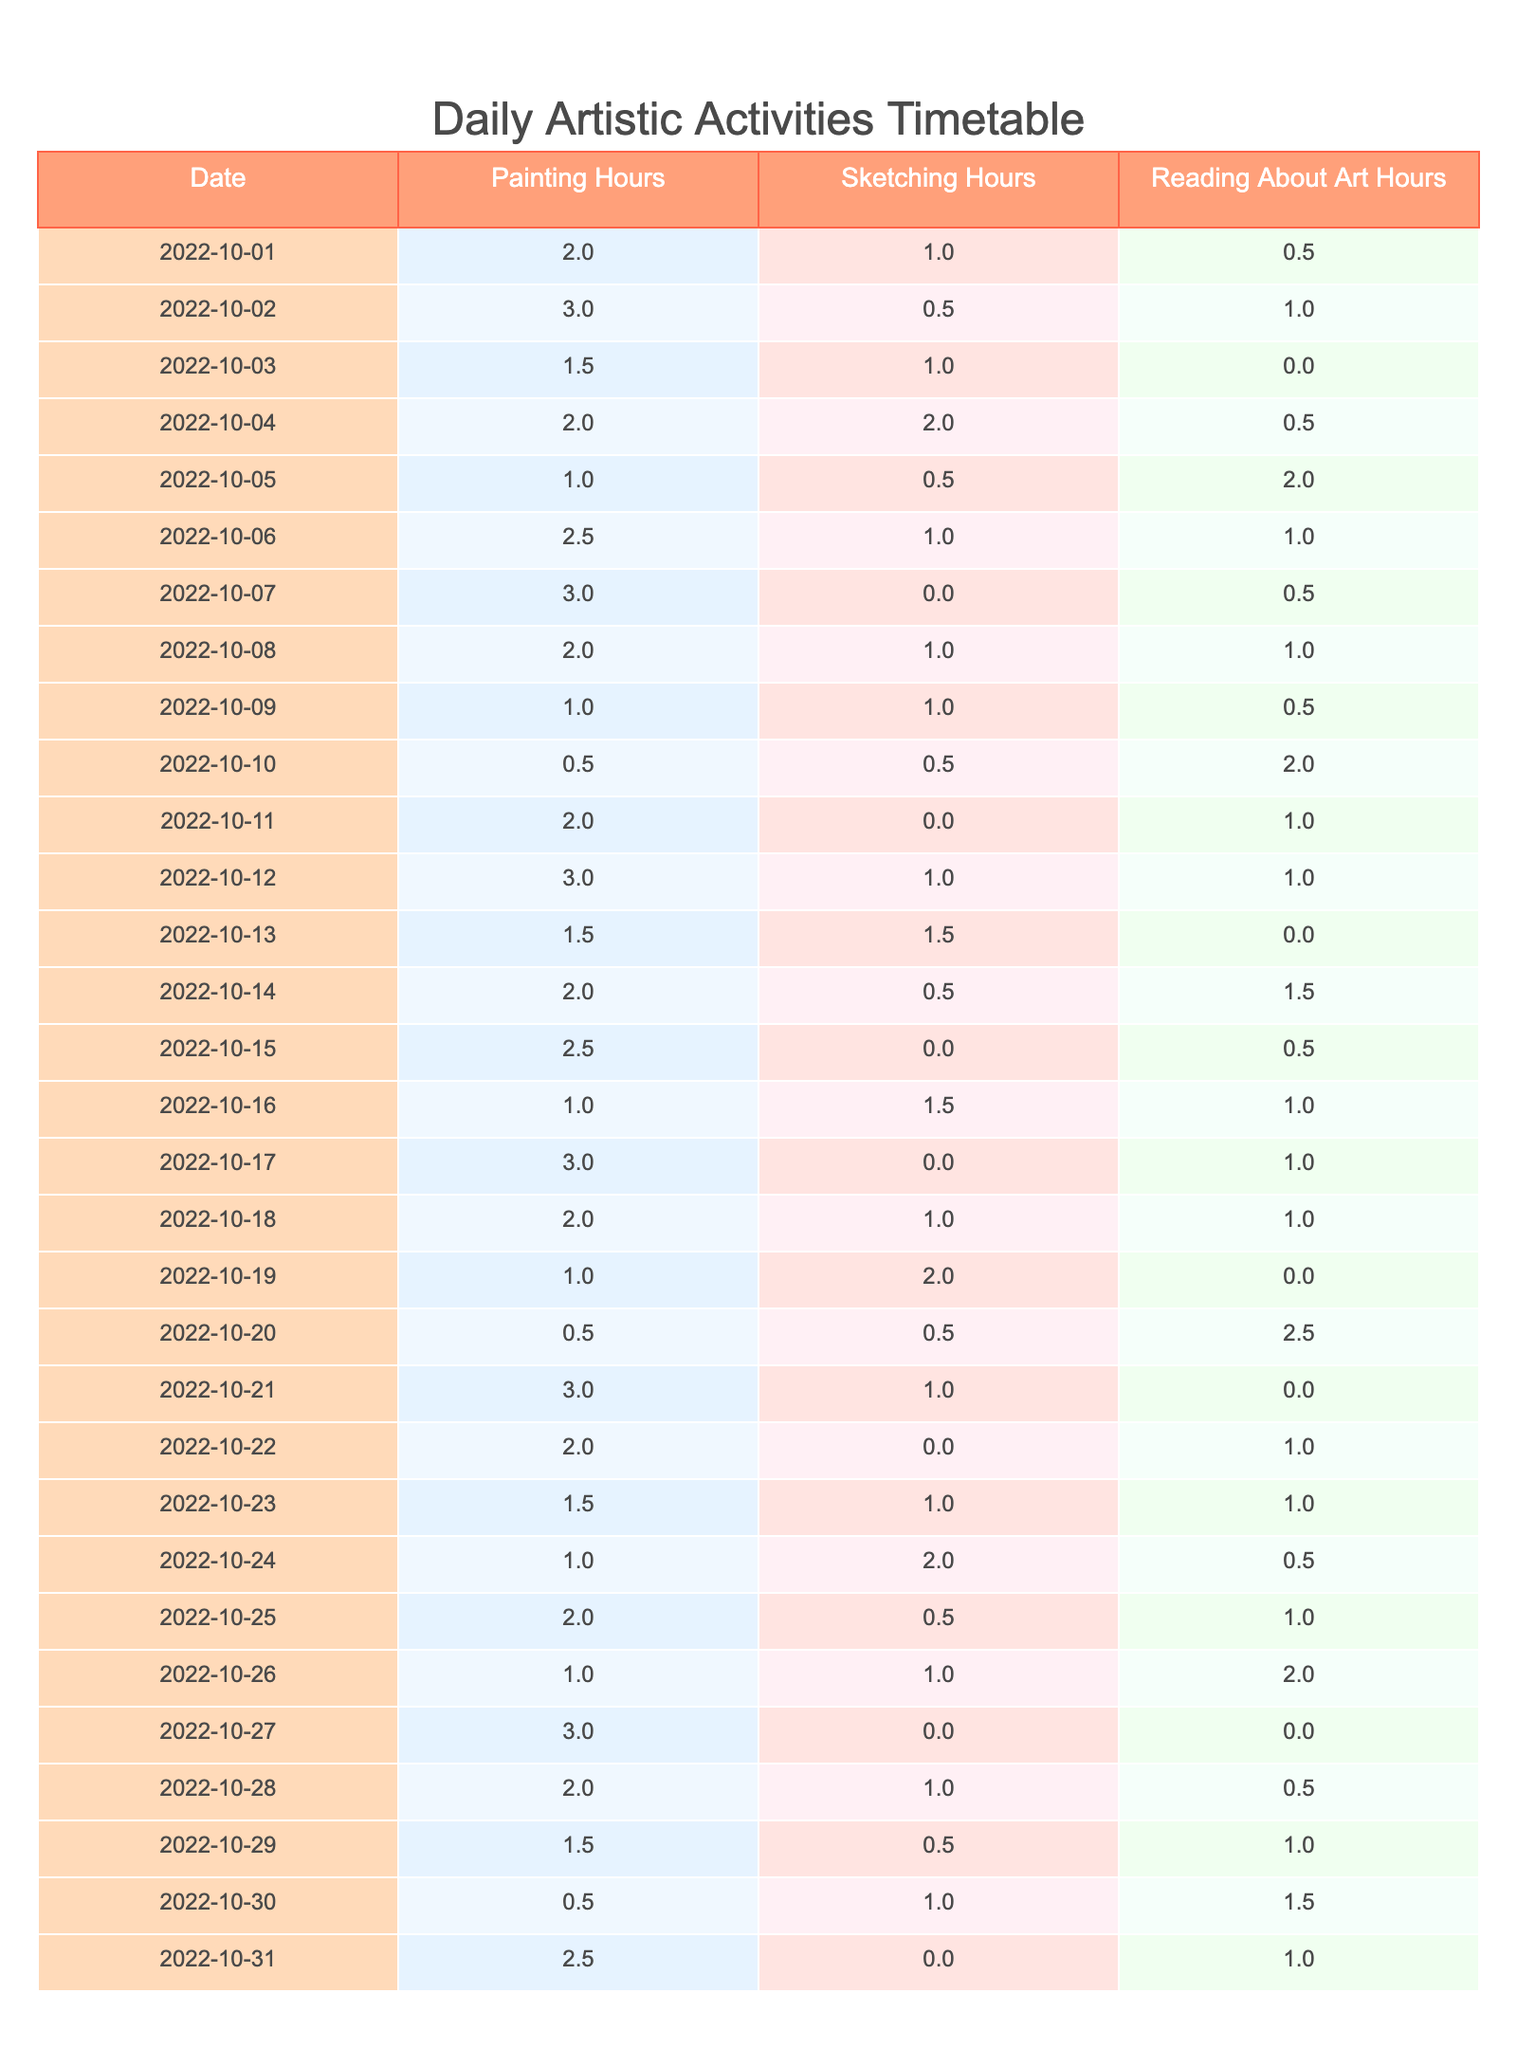What is the total amount of time spent painting on October 5, 2022? On October 5, 2022, the table shows that the hours spent painting is 1 hour.
Answer: 1 hour What is the average time spent on sketching over the first week of October? From October 1 to 7, the sketching hours are 1, 0.5, 1, 2, 0.5, 1, and 0, totaling 6 hours. With 7 days, the average is 6/7 = approximately 0.86 hours.
Answer: 0.86 hours Did I spend more than 2 hours reading about art on any single day? By checking the reading about art hours for each day, the maximum is 2.5 hours on October 20, which is greater than 2 hours.
Answer: Yes How many days did I spend more time painting than reading about art in the month of October? By reviewing the table for October, the days spent painting more than reading about art are: October 1, 2, 4, 6, 12, 14, 15, 18, 21, 22, and 23, totaling 11 days.
Answer: 11 days What is the total time spent on all three activities from October 1 to October 31? Adding all the hours from painting, sketching, and reading about art for each day in the table gives us a total of 57.5 hours over 31 days.
Answer: 57.5 hours What was the most time spent on sketching in a single day? On October 14, I spent 1.5 hours sketching, which is the highest amount recorded in the table.
Answer: 1.5 hours Was there a day when I did not engage in painting at all? Yes, the table indicates that on October 10 and October 27, I did not spend any time painting.
Answer: Yes How many days did I spend exactly 2 hours reading about art? By examining the table, I spent exactly 2 hours reading about art on October 10 and October 20, totaling 2 days.
Answer: 2 days What is the difference in hours spent on painting and reading about art on October 30? On October 30, I spent 0.5 hours on painting and 1.5 hours on reading about art. The difference is 1.5 - 0.5 = 1 hour.
Answer: 1 hour 